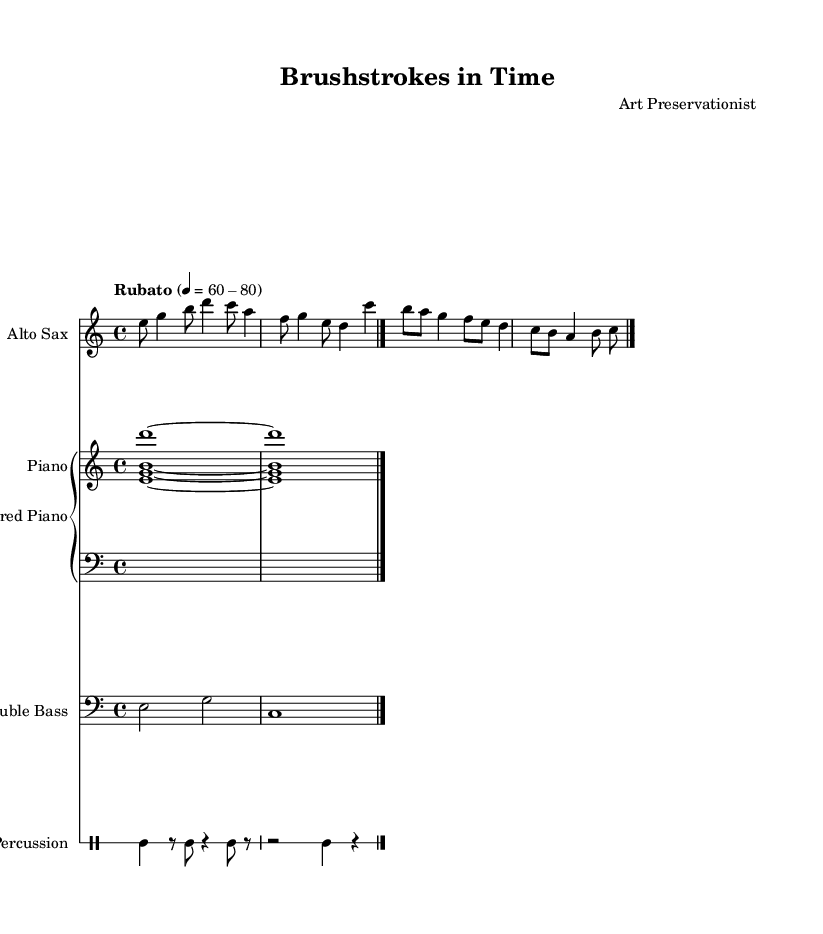What is the time signature of this music? The time signature is indicated at the beginning of the score and is written as 4/4. This means there are four beats in each measure, and each beat is a quarter note.
Answer: 4/4 What instruments are involved in this piece? The instruments are listed at the beginning of each staff. They include Alto Sax, Prepared Piano (which has an upper and lower staff), Double Bass, and Percussion.
Answer: Alto Sax, Prepared Piano, Double Bass, Percussion What is the tempo marking for this piece? The tempo marking is given as "Rubato" with a metronome marking of 60-80. Rubato indicates that the performer has flexibility in tempo, while the range provides a specific pace for guidance.
Answer: Rubato What is the function of the prepared piano in this composition? The prepared piano is likely used to produce unique, percussive sounds that enhance the texture of the piece. This technique involves placing objects on or between the strings of the piano, altering its timbre.
Answer: Textural enhancement Which instrument has the lowest pitch range in the score? The Double Bass is indicated with a bass clef, which signifies it plays in a lower pitch range compared to the other instruments.
Answer: Double Bass How does the percussion part contribute to the overall texture of the piece? The percussion part features a mix of rhythmic patterns and rests, contributing to the piece's avant-garde texture by adding an irregular rhythmic element. This non-traditional rhythm complements the jazz style.
Answer: Irregular rhythm What musical technique is used in the Alto Sax part? The Alto Sax part utilizes a variety of pitches and rhythmic variations, which are characteristic of improvisation within the jazz genre, enhancing the spontaneous feeling of the music.
Answer: Improvisation 